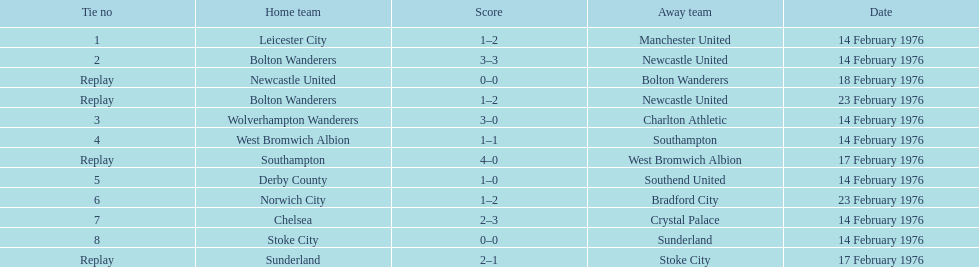How many games were repetitions? 4. 